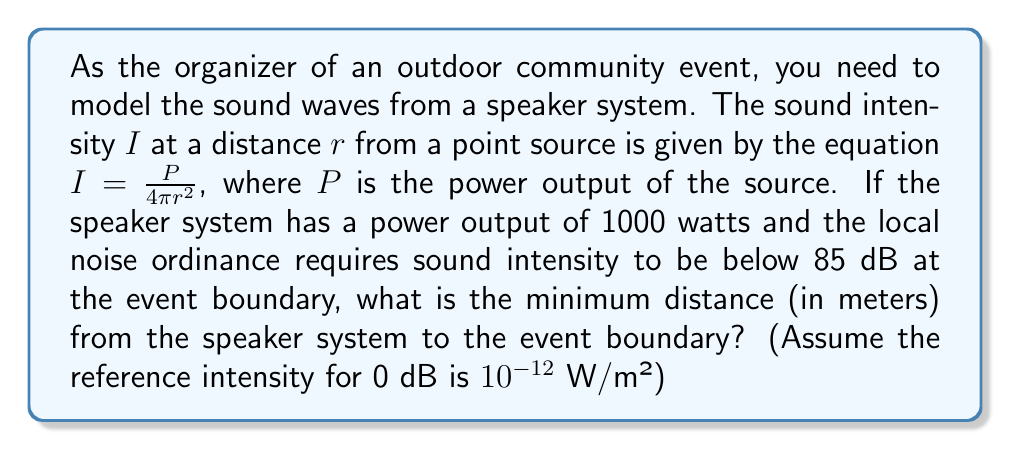Provide a solution to this math problem. Let's approach this step-by-step:

1) First, we need to convert 85 dB to watts per square meter. The formula for sound intensity level in decibels is:

   $$ L = 10 \log_{10}\left(\frac{I}{I_0}\right) $$

   where $L$ is the sound level in dB, $I$ is the intensity in W/m², and $I_0$ is the reference intensity ($10^{-12}$ W/m²).

2) We can rearrange this to solve for $I$:

   $$ I = I_0 \cdot 10^{L/10} $$

3) Plugging in our values:

   $$ I = 10^{-12} \cdot 10^{85/10} = 3.16228 \times 10^{-4} \text{ W/m²} $$

4) Now we can use the equation given in the question:

   $$ I = \frac{P}{4\pi r^2} $$

5) We know $I$ and $P$, so we can solve for $r$:

   $$ 3.16228 \times 10^{-4} = \frac{1000}{4\pi r^2} $$

6) Rearranging to isolate $r$:

   $$ r^2 = \frac{1000}{4\pi \cdot 3.16228 \times 10^{-4}} $$
   
   $$ r = \sqrt{\frac{1000}{4\pi \cdot 3.16228 \times 10^{-4}}} \approx 251.19 \text{ meters} $$

Therefore, the minimum distance from the speaker system to the event boundary should be approximately 251.19 meters.
Answer: 251.19 m 